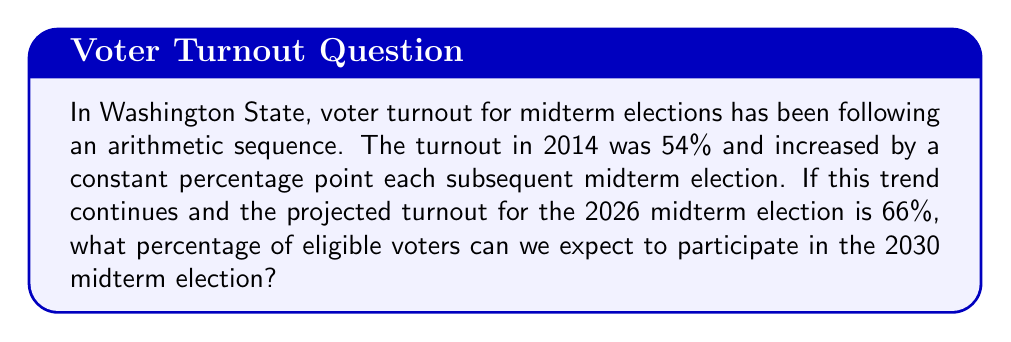Give your solution to this math problem. Let's approach this step-by-step:

1) First, we need to identify the arithmetic sequence:
   - 2014 (1st term): 54%
   - 2026 (4th term): 66%

2) In an arithmetic sequence, the difference between each term is constant. Let's call this common difference $d$.

3) We can find $d$ using the formula:
   $a_n = a_1 + (n-1)d$
   Where $a_n$ is the nth term, $a_1$ is the first term, and $n$ is the term number.

4) Plugging in our known values:
   $66 = 54 + (4-1)d$
   $66 = 54 + 3d$
   $12 = 3d$
   $d = 4$

5) So, the turnout increases by 4 percentage points each midterm election.

6) Now, let's find which term the 2030 election would be:
   2014 - 1st term
   2018 - 2nd term
   2022 - 3rd term
   2026 - 4th term
   2030 - 5th term

7) We can now use the arithmetic sequence formula to find the 5th term:
   $a_5 = a_1 + (5-1)d$
   $a_5 = 54 + (4 * 4)$
   $a_5 = 54 + 16$
   $a_5 = 70$

Therefore, we can expect 70% of eligible voters to participate in the 2030 midterm election.
Answer: 70% 